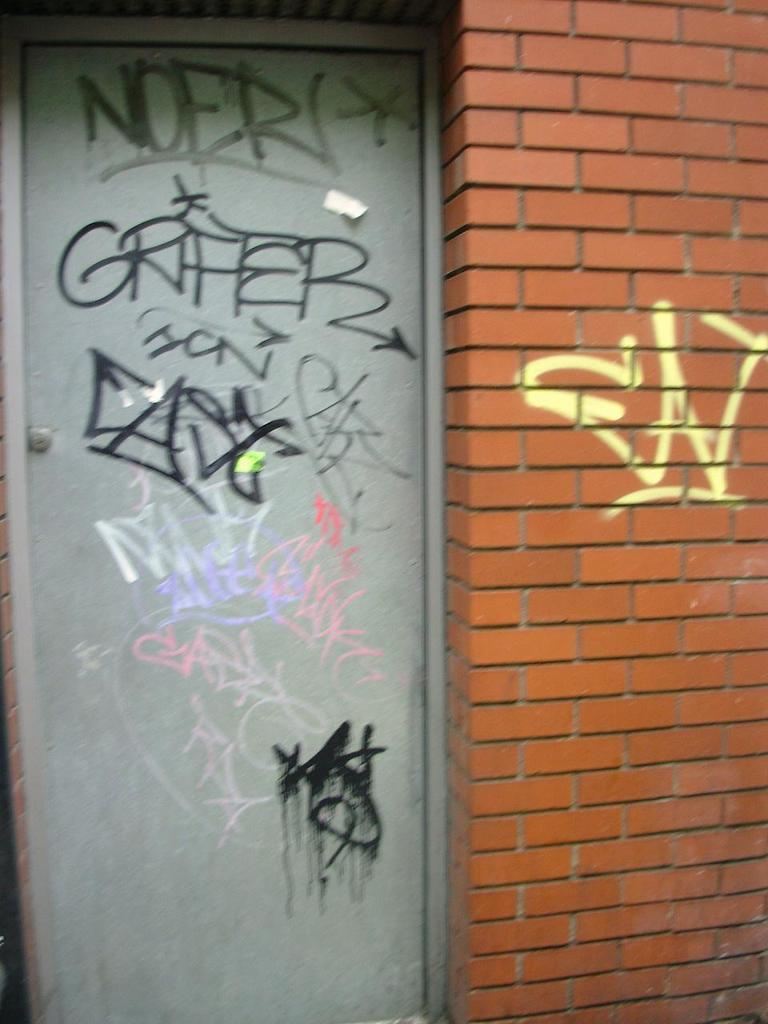What material is the wall in the image made of? The wall in the image is made up of bricks. What color is the door in the image? The door in the image is grey colored. What can be seen on the door in the image? There is writing on the door. What can be seen on the wall in the image? There is writing on the wall. What type of fuel is being used to power the brick in the image? There is no fuel or power source mentioned in the image, as it only features a brick wall and a door. 